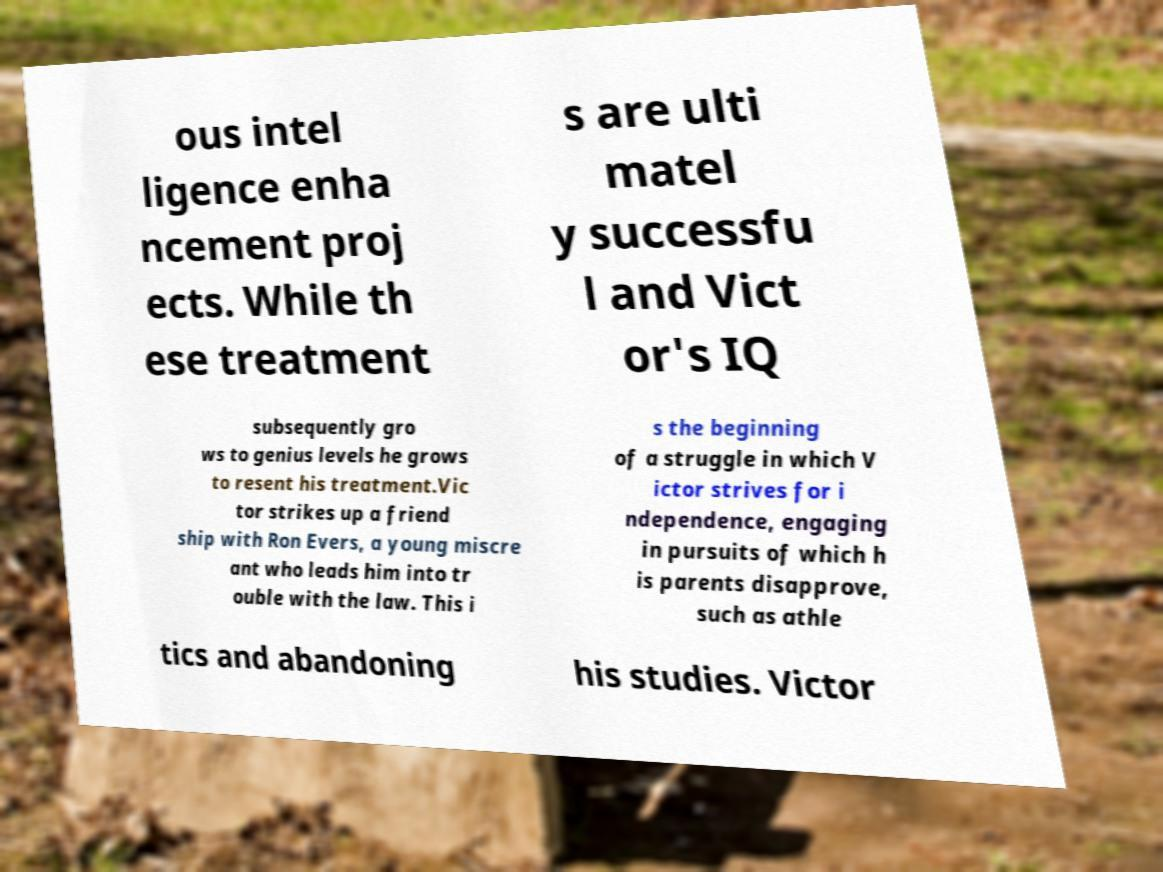Could you extract and type out the text from this image? ous intel ligence enha ncement proj ects. While th ese treatment s are ulti matel y successfu l and Vict or's IQ subsequently gro ws to genius levels he grows to resent his treatment.Vic tor strikes up a friend ship with Ron Evers, a young miscre ant who leads him into tr ouble with the law. This i s the beginning of a struggle in which V ictor strives for i ndependence, engaging in pursuits of which h is parents disapprove, such as athle tics and abandoning his studies. Victor 